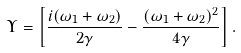<formula> <loc_0><loc_0><loc_500><loc_500>\Upsilon = \left [ \frac { i ( \omega _ { 1 } + \omega _ { 2 } ) } { 2 \gamma } - \frac { ( \omega _ { 1 } + \omega _ { 2 } ) ^ { 2 } } { 4 \gamma } \right ] .</formula> 